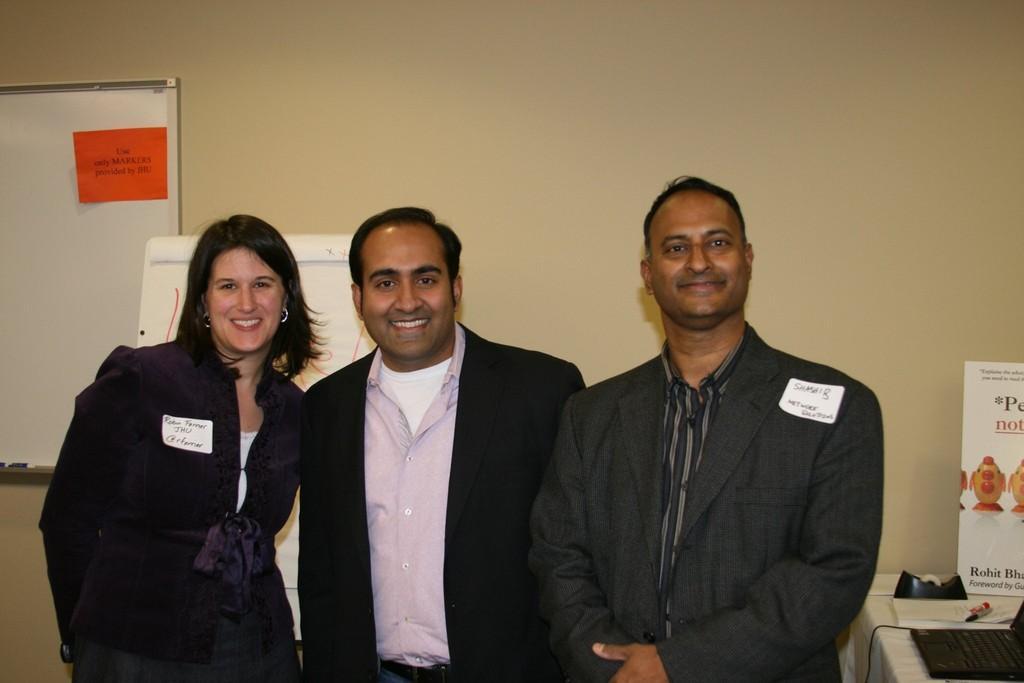In one or two sentences, can you explain what this image depicts? In this picture I can see three persons standing and smiling, there is a laptop, book, pen, board and a scotch tape dispenser on the table, there are boards, and in the background there is a wall. 